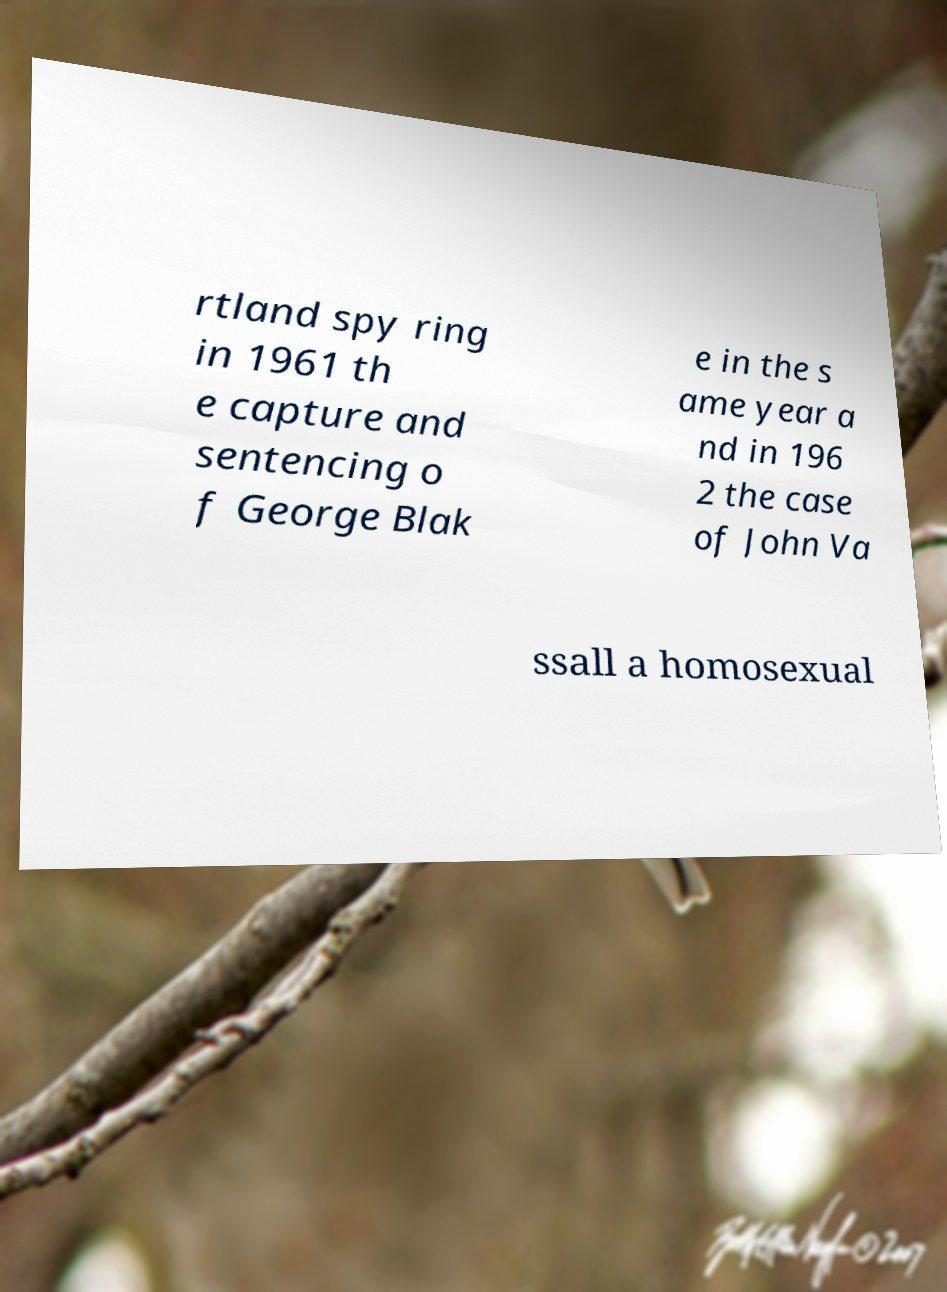For documentation purposes, I need the text within this image transcribed. Could you provide that? rtland spy ring in 1961 th e capture and sentencing o f George Blak e in the s ame year a nd in 196 2 the case of John Va ssall a homosexual 